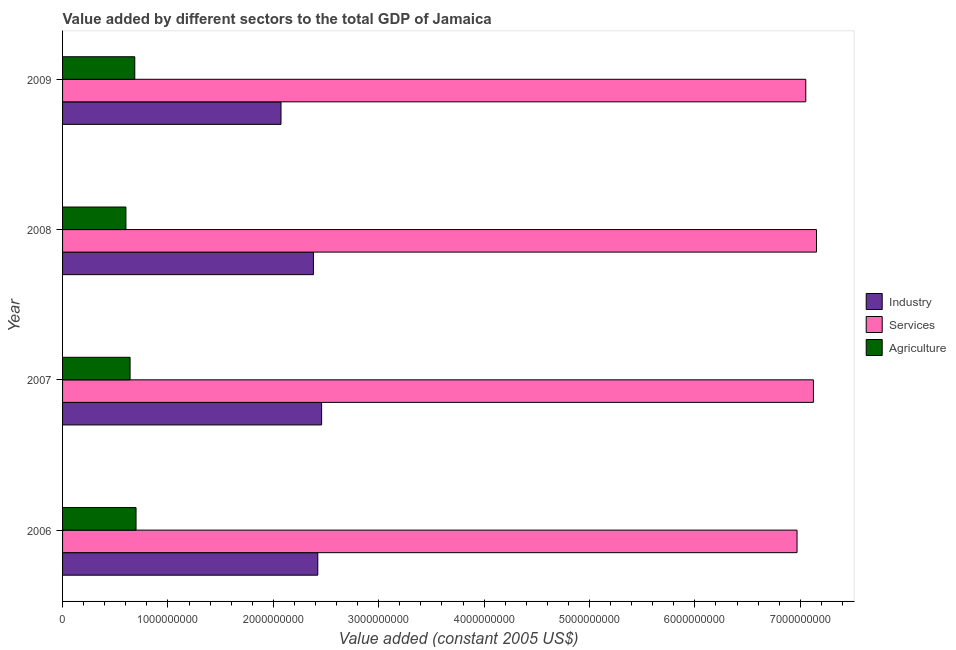Are the number of bars on each tick of the Y-axis equal?
Make the answer very short. Yes. How many bars are there on the 4th tick from the top?
Your answer should be very brief. 3. What is the value added by industrial sector in 2007?
Keep it short and to the point. 2.46e+09. Across all years, what is the maximum value added by industrial sector?
Offer a terse response. 2.46e+09. Across all years, what is the minimum value added by agricultural sector?
Provide a succinct answer. 6.01e+08. In which year was the value added by agricultural sector minimum?
Give a very brief answer. 2008. What is the total value added by services in the graph?
Provide a short and direct response. 2.83e+1. What is the difference between the value added by industrial sector in 2008 and that in 2009?
Offer a very short reply. 3.08e+08. What is the difference between the value added by industrial sector in 2007 and the value added by agricultural sector in 2008?
Give a very brief answer. 1.86e+09. What is the average value added by services per year?
Your answer should be compact. 7.07e+09. In the year 2007, what is the difference between the value added by industrial sector and value added by services?
Keep it short and to the point. -4.67e+09. In how many years, is the value added by industrial sector greater than 2800000000 US$?
Offer a very short reply. 0. What is the difference between the highest and the second highest value added by agricultural sector?
Offer a terse response. 1.20e+07. What is the difference between the highest and the lowest value added by services?
Provide a succinct answer. 1.85e+08. In how many years, is the value added by industrial sector greater than the average value added by industrial sector taken over all years?
Provide a succinct answer. 3. What does the 1st bar from the top in 2007 represents?
Offer a very short reply. Agriculture. What does the 3rd bar from the bottom in 2007 represents?
Your answer should be compact. Agriculture. How many bars are there?
Offer a very short reply. 12. How many years are there in the graph?
Your answer should be very brief. 4. Are the values on the major ticks of X-axis written in scientific E-notation?
Your answer should be very brief. No. Does the graph contain any zero values?
Offer a terse response. No. How many legend labels are there?
Your answer should be compact. 3. What is the title of the graph?
Give a very brief answer. Value added by different sectors to the total GDP of Jamaica. Does "Gaseous fuel" appear as one of the legend labels in the graph?
Keep it short and to the point. No. What is the label or title of the X-axis?
Your answer should be very brief. Value added (constant 2005 US$). What is the label or title of the Y-axis?
Offer a very short reply. Year. What is the Value added (constant 2005 US$) in Industry in 2006?
Offer a terse response. 2.42e+09. What is the Value added (constant 2005 US$) of Services in 2006?
Your response must be concise. 6.97e+09. What is the Value added (constant 2005 US$) of Agriculture in 2006?
Your answer should be very brief. 6.97e+08. What is the Value added (constant 2005 US$) in Industry in 2007?
Give a very brief answer. 2.46e+09. What is the Value added (constant 2005 US$) of Services in 2007?
Your answer should be compact. 7.12e+09. What is the Value added (constant 2005 US$) in Agriculture in 2007?
Ensure brevity in your answer.  6.41e+08. What is the Value added (constant 2005 US$) in Industry in 2008?
Your response must be concise. 2.38e+09. What is the Value added (constant 2005 US$) of Services in 2008?
Your response must be concise. 7.15e+09. What is the Value added (constant 2005 US$) of Agriculture in 2008?
Ensure brevity in your answer.  6.01e+08. What is the Value added (constant 2005 US$) in Industry in 2009?
Your response must be concise. 2.07e+09. What is the Value added (constant 2005 US$) in Services in 2009?
Your answer should be compact. 7.05e+09. What is the Value added (constant 2005 US$) in Agriculture in 2009?
Your answer should be compact. 6.85e+08. Across all years, what is the maximum Value added (constant 2005 US$) of Industry?
Make the answer very short. 2.46e+09. Across all years, what is the maximum Value added (constant 2005 US$) in Services?
Ensure brevity in your answer.  7.15e+09. Across all years, what is the maximum Value added (constant 2005 US$) of Agriculture?
Give a very brief answer. 6.97e+08. Across all years, what is the minimum Value added (constant 2005 US$) in Industry?
Give a very brief answer. 2.07e+09. Across all years, what is the minimum Value added (constant 2005 US$) of Services?
Your answer should be compact. 6.97e+09. Across all years, what is the minimum Value added (constant 2005 US$) in Agriculture?
Provide a short and direct response. 6.01e+08. What is the total Value added (constant 2005 US$) in Industry in the graph?
Give a very brief answer. 9.33e+09. What is the total Value added (constant 2005 US$) of Services in the graph?
Keep it short and to the point. 2.83e+1. What is the total Value added (constant 2005 US$) in Agriculture in the graph?
Give a very brief answer. 2.62e+09. What is the difference between the Value added (constant 2005 US$) of Industry in 2006 and that in 2007?
Your answer should be compact. -3.65e+07. What is the difference between the Value added (constant 2005 US$) of Services in 2006 and that in 2007?
Your answer should be compact. -1.55e+08. What is the difference between the Value added (constant 2005 US$) of Agriculture in 2006 and that in 2007?
Keep it short and to the point. 5.65e+07. What is the difference between the Value added (constant 2005 US$) in Industry in 2006 and that in 2008?
Give a very brief answer. 4.12e+07. What is the difference between the Value added (constant 2005 US$) of Services in 2006 and that in 2008?
Offer a terse response. -1.85e+08. What is the difference between the Value added (constant 2005 US$) of Agriculture in 2006 and that in 2008?
Offer a terse response. 9.60e+07. What is the difference between the Value added (constant 2005 US$) in Industry in 2006 and that in 2009?
Ensure brevity in your answer.  3.49e+08. What is the difference between the Value added (constant 2005 US$) of Services in 2006 and that in 2009?
Offer a very short reply. -8.30e+07. What is the difference between the Value added (constant 2005 US$) of Agriculture in 2006 and that in 2009?
Ensure brevity in your answer.  1.20e+07. What is the difference between the Value added (constant 2005 US$) of Industry in 2007 and that in 2008?
Your answer should be very brief. 7.76e+07. What is the difference between the Value added (constant 2005 US$) in Services in 2007 and that in 2008?
Keep it short and to the point. -2.92e+07. What is the difference between the Value added (constant 2005 US$) of Agriculture in 2007 and that in 2008?
Provide a short and direct response. 3.95e+07. What is the difference between the Value added (constant 2005 US$) of Industry in 2007 and that in 2009?
Offer a very short reply. 3.86e+08. What is the difference between the Value added (constant 2005 US$) in Services in 2007 and that in 2009?
Your response must be concise. 7.25e+07. What is the difference between the Value added (constant 2005 US$) of Agriculture in 2007 and that in 2009?
Provide a short and direct response. -4.45e+07. What is the difference between the Value added (constant 2005 US$) of Industry in 2008 and that in 2009?
Ensure brevity in your answer.  3.08e+08. What is the difference between the Value added (constant 2005 US$) in Services in 2008 and that in 2009?
Provide a succinct answer. 1.02e+08. What is the difference between the Value added (constant 2005 US$) in Agriculture in 2008 and that in 2009?
Give a very brief answer. -8.40e+07. What is the difference between the Value added (constant 2005 US$) in Industry in 2006 and the Value added (constant 2005 US$) in Services in 2007?
Make the answer very short. -4.70e+09. What is the difference between the Value added (constant 2005 US$) in Industry in 2006 and the Value added (constant 2005 US$) in Agriculture in 2007?
Offer a very short reply. 1.78e+09. What is the difference between the Value added (constant 2005 US$) of Services in 2006 and the Value added (constant 2005 US$) of Agriculture in 2007?
Ensure brevity in your answer.  6.33e+09. What is the difference between the Value added (constant 2005 US$) of Industry in 2006 and the Value added (constant 2005 US$) of Services in 2008?
Offer a very short reply. -4.73e+09. What is the difference between the Value added (constant 2005 US$) of Industry in 2006 and the Value added (constant 2005 US$) of Agriculture in 2008?
Provide a succinct answer. 1.82e+09. What is the difference between the Value added (constant 2005 US$) in Services in 2006 and the Value added (constant 2005 US$) in Agriculture in 2008?
Your answer should be very brief. 6.37e+09. What is the difference between the Value added (constant 2005 US$) in Industry in 2006 and the Value added (constant 2005 US$) in Services in 2009?
Offer a very short reply. -4.63e+09. What is the difference between the Value added (constant 2005 US$) in Industry in 2006 and the Value added (constant 2005 US$) in Agriculture in 2009?
Your response must be concise. 1.74e+09. What is the difference between the Value added (constant 2005 US$) of Services in 2006 and the Value added (constant 2005 US$) of Agriculture in 2009?
Ensure brevity in your answer.  6.28e+09. What is the difference between the Value added (constant 2005 US$) of Industry in 2007 and the Value added (constant 2005 US$) of Services in 2008?
Your answer should be very brief. -4.70e+09. What is the difference between the Value added (constant 2005 US$) in Industry in 2007 and the Value added (constant 2005 US$) in Agriculture in 2008?
Ensure brevity in your answer.  1.86e+09. What is the difference between the Value added (constant 2005 US$) in Services in 2007 and the Value added (constant 2005 US$) in Agriculture in 2008?
Keep it short and to the point. 6.52e+09. What is the difference between the Value added (constant 2005 US$) in Industry in 2007 and the Value added (constant 2005 US$) in Services in 2009?
Give a very brief answer. -4.59e+09. What is the difference between the Value added (constant 2005 US$) of Industry in 2007 and the Value added (constant 2005 US$) of Agriculture in 2009?
Provide a short and direct response. 1.77e+09. What is the difference between the Value added (constant 2005 US$) of Services in 2007 and the Value added (constant 2005 US$) of Agriculture in 2009?
Keep it short and to the point. 6.44e+09. What is the difference between the Value added (constant 2005 US$) of Industry in 2008 and the Value added (constant 2005 US$) of Services in 2009?
Provide a short and direct response. -4.67e+09. What is the difference between the Value added (constant 2005 US$) of Industry in 2008 and the Value added (constant 2005 US$) of Agriculture in 2009?
Provide a succinct answer. 1.70e+09. What is the difference between the Value added (constant 2005 US$) of Services in 2008 and the Value added (constant 2005 US$) of Agriculture in 2009?
Your response must be concise. 6.47e+09. What is the average Value added (constant 2005 US$) in Industry per year?
Keep it short and to the point. 2.33e+09. What is the average Value added (constant 2005 US$) of Services per year?
Offer a very short reply. 7.07e+09. What is the average Value added (constant 2005 US$) of Agriculture per year?
Provide a succinct answer. 6.56e+08. In the year 2006, what is the difference between the Value added (constant 2005 US$) of Industry and Value added (constant 2005 US$) of Services?
Keep it short and to the point. -4.55e+09. In the year 2006, what is the difference between the Value added (constant 2005 US$) of Industry and Value added (constant 2005 US$) of Agriculture?
Offer a very short reply. 1.72e+09. In the year 2006, what is the difference between the Value added (constant 2005 US$) in Services and Value added (constant 2005 US$) in Agriculture?
Give a very brief answer. 6.27e+09. In the year 2007, what is the difference between the Value added (constant 2005 US$) in Industry and Value added (constant 2005 US$) in Services?
Offer a very short reply. -4.67e+09. In the year 2007, what is the difference between the Value added (constant 2005 US$) of Industry and Value added (constant 2005 US$) of Agriculture?
Offer a very short reply. 1.82e+09. In the year 2007, what is the difference between the Value added (constant 2005 US$) in Services and Value added (constant 2005 US$) in Agriculture?
Your answer should be very brief. 6.48e+09. In the year 2008, what is the difference between the Value added (constant 2005 US$) in Industry and Value added (constant 2005 US$) in Services?
Your response must be concise. -4.77e+09. In the year 2008, what is the difference between the Value added (constant 2005 US$) in Industry and Value added (constant 2005 US$) in Agriculture?
Offer a terse response. 1.78e+09. In the year 2008, what is the difference between the Value added (constant 2005 US$) in Services and Value added (constant 2005 US$) in Agriculture?
Keep it short and to the point. 6.55e+09. In the year 2009, what is the difference between the Value added (constant 2005 US$) in Industry and Value added (constant 2005 US$) in Services?
Give a very brief answer. -4.98e+09. In the year 2009, what is the difference between the Value added (constant 2005 US$) in Industry and Value added (constant 2005 US$) in Agriculture?
Offer a terse response. 1.39e+09. In the year 2009, what is the difference between the Value added (constant 2005 US$) in Services and Value added (constant 2005 US$) in Agriculture?
Your answer should be very brief. 6.37e+09. What is the ratio of the Value added (constant 2005 US$) in Industry in 2006 to that in 2007?
Your answer should be very brief. 0.99. What is the ratio of the Value added (constant 2005 US$) of Services in 2006 to that in 2007?
Your response must be concise. 0.98. What is the ratio of the Value added (constant 2005 US$) of Agriculture in 2006 to that in 2007?
Provide a succinct answer. 1.09. What is the ratio of the Value added (constant 2005 US$) in Industry in 2006 to that in 2008?
Make the answer very short. 1.02. What is the ratio of the Value added (constant 2005 US$) in Services in 2006 to that in 2008?
Ensure brevity in your answer.  0.97. What is the ratio of the Value added (constant 2005 US$) of Agriculture in 2006 to that in 2008?
Provide a succinct answer. 1.16. What is the ratio of the Value added (constant 2005 US$) of Industry in 2006 to that in 2009?
Your answer should be compact. 1.17. What is the ratio of the Value added (constant 2005 US$) in Agriculture in 2006 to that in 2009?
Give a very brief answer. 1.02. What is the ratio of the Value added (constant 2005 US$) in Industry in 2007 to that in 2008?
Provide a succinct answer. 1.03. What is the ratio of the Value added (constant 2005 US$) in Agriculture in 2007 to that in 2008?
Ensure brevity in your answer.  1.07. What is the ratio of the Value added (constant 2005 US$) in Industry in 2007 to that in 2009?
Your response must be concise. 1.19. What is the ratio of the Value added (constant 2005 US$) of Services in 2007 to that in 2009?
Your response must be concise. 1.01. What is the ratio of the Value added (constant 2005 US$) in Agriculture in 2007 to that in 2009?
Ensure brevity in your answer.  0.94. What is the ratio of the Value added (constant 2005 US$) in Industry in 2008 to that in 2009?
Give a very brief answer. 1.15. What is the ratio of the Value added (constant 2005 US$) in Services in 2008 to that in 2009?
Provide a succinct answer. 1.01. What is the ratio of the Value added (constant 2005 US$) of Agriculture in 2008 to that in 2009?
Keep it short and to the point. 0.88. What is the difference between the highest and the second highest Value added (constant 2005 US$) of Industry?
Your answer should be very brief. 3.65e+07. What is the difference between the highest and the second highest Value added (constant 2005 US$) in Services?
Ensure brevity in your answer.  2.92e+07. What is the difference between the highest and the second highest Value added (constant 2005 US$) in Agriculture?
Make the answer very short. 1.20e+07. What is the difference between the highest and the lowest Value added (constant 2005 US$) in Industry?
Make the answer very short. 3.86e+08. What is the difference between the highest and the lowest Value added (constant 2005 US$) of Services?
Give a very brief answer. 1.85e+08. What is the difference between the highest and the lowest Value added (constant 2005 US$) in Agriculture?
Provide a short and direct response. 9.60e+07. 